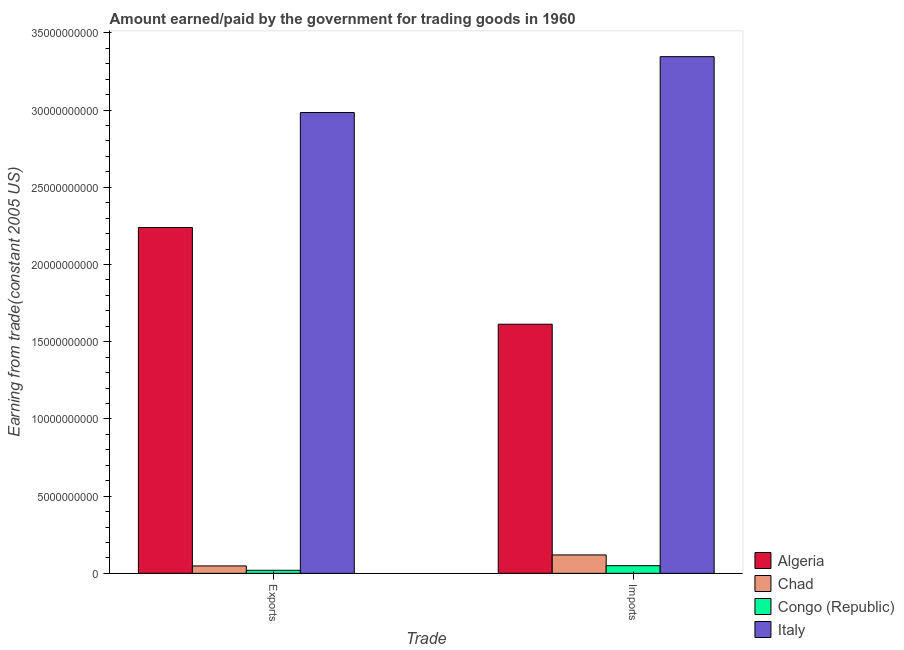How many different coloured bars are there?
Ensure brevity in your answer.  4. How many groups of bars are there?
Make the answer very short. 2. How many bars are there on the 1st tick from the right?
Make the answer very short. 4. What is the label of the 1st group of bars from the left?
Make the answer very short. Exports. What is the amount earned from exports in Chad?
Your answer should be compact. 4.79e+08. Across all countries, what is the maximum amount paid for imports?
Give a very brief answer. 3.35e+1. Across all countries, what is the minimum amount paid for imports?
Your response must be concise. 4.95e+08. In which country was the amount earned from exports minimum?
Keep it short and to the point. Congo (Republic). What is the total amount earned from exports in the graph?
Ensure brevity in your answer.  5.29e+1. What is the difference between the amount earned from exports in Algeria and that in Chad?
Keep it short and to the point. 2.19e+1. What is the difference between the amount paid for imports in Algeria and the amount earned from exports in Congo (Republic)?
Your answer should be compact. 1.59e+1. What is the average amount paid for imports per country?
Provide a short and direct response. 1.28e+1. What is the difference between the amount paid for imports and amount earned from exports in Italy?
Your answer should be compact. 3.62e+09. In how many countries, is the amount earned from exports greater than 19000000000 US$?
Your response must be concise. 2. What is the ratio of the amount earned from exports in Congo (Republic) to that in Algeria?
Make the answer very short. 0.01. What does the 2nd bar from the left in Imports represents?
Offer a very short reply. Chad. What does the 4th bar from the right in Exports represents?
Your answer should be very brief. Algeria. How many bars are there?
Your answer should be very brief. 8. How many countries are there in the graph?
Your response must be concise. 4. Does the graph contain grids?
Ensure brevity in your answer.  No. Where does the legend appear in the graph?
Provide a short and direct response. Bottom right. How many legend labels are there?
Offer a terse response. 4. What is the title of the graph?
Offer a very short reply. Amount earned/paid by the government for trading goods in 1960. Does "Uzbekistan" appear as one of the legend labels in the graph?
Make the answer very short. No. What is the label or title of the X-axis?
Give a very brief answer. Trade. What is the label or title of the Y-axis?
Make the answer very short. Earning from trade(constant 2005 US). What is the Earning from trade(constant 2005 US) in Algeria in Exports?
Keep it short and to the point. 2.24e+1. What is the Earning from trade(constant 2005 US) of Chad in Exports?
Make the answer very short. 4.79e+08. What is the Earning from trade(constant 2005 US) in Congo (Republic) in Exports?
Keep it short and to the point. 1.98e+08. What is the Earning from trade(constant 2005 US) in Italy in Exports?
Keep it short and to the point. 2.98e+1. What is the Earning from trade(constant 2005 US) in Algeria in Imports?
Your answer should be very brief. 1.61e+1. What is the Earning from trade(constant 2005 US) of Chad in Imports?
Ensure brevity in your answer.  1.19e+09. What is the Earning from trade(constant 2005 US) of Congo (Republic) in Imports?
Your answer should be very brief. 4.95e+08. What is the Earning from trade(constant 2005 US) of Italy in Imports?
Keep it short and to the point. 3.35e+1. Across all Trade, what is the maximum Earning from trade(constant 2005 US) in Algeria?
Offer a very short reply. 2.24e+1. Across all Trade, what is the maximum Earning from trade(constant 2005 US) of Chad?
Your response must be concise. 1.19e+09. Across all Trade, what is the maximum Earning from trade(constant 2005 US) of Congo (Republic)?
Offer a very short reply. 4.95e+08. Across all Trade, what is the maximum Earning from trade(constant 2005 US) in Italy?
Give a very brief answer. 3.35e+1. Across all Trade, what is the minimum Earning from trade(constant 2005 US) of Algeria?
Your answer should be compact. 1.61e+1. Across all Trade, what is the minimum Earning from trade(constant 2005 US) of Chad?
Make the answer very short. 4.79e+08. Across all Trade, what is the minimum Earning from trade(constant 2005 US) in Congo (Republic)?
Keep it short and to the point. 1.98e+08. Across all Trade, what is the minimum Earning from trade(constant 2005 US) of Italy?
Offer a very short reply. 2.98e+1. What is the total Earning from trade(constant 2005 US) of Algeria in the graph?
Provide a short and direct response. 3.85e+1. What is the total Earning from trade(constant 2005 US) of Chad in the graph?
Provide a short and direct response. 1.67e+09. What is the total Earning from trade(constant 2005 US) in Congo (Republic) in the graph?
Your answer should be compact. 6.93e+08. What is the total Earning from trade(constant 2005 US) in Italy in the graph?
Provide a short and direct response. 6.33e+1. What is the difference between the Earning from trade(constant 2005 US) of Algeria in Exports and that in Imports?
Provide a short and direct response. 6.26e+09. What is the difference between the Earning from trade(constant 2005 US) in Chad in Exports and that in Imports?
Your answer should be very brief. -7.13e+08. What is the difference between the Earning from trade(constant 2005 US) in Congo (Republic) in Exports and that in Imports?
Provide a short and direct response. -2.96e+08. What is the difference between the Earning from trade(constant 2005 US) of Italy in Exports and that in Imports?
Offer a terse response. -3.62e+09. What is the difference between the Earning from trade(constant 2005 US) of Algeria in Exports and the Earning from trade(constant 2005 US) of Chad in Imports?
Provide a short and direct response. 2.12e+1. What is the difference between the Earning from trade(constant 2005 US) in Algeria in Exports and the Earning from trade(constant 2005 US) in Congo (Republic) in Imports?
Provide a succinct answer. 2.19e+1. What is the difference between the Earning from trade(constant 2005 US) of Algeria in Exports and the Earning from trade(constant 2005 US) of Italy in Imports?
Keep it short and to the point. -1.11e+1. What is the difference between the Earning from trade(constant 2005 US) in Chad in Exports and the Earning from trade(constant 2005 US) in Congo (Republic) in Imports?
Provide a succinct answer. -1.58e+07. What is the difference between the Earning from trade(constant 2005 US) in Chad in Exports and the Earning from trade(constant 2005 US) in Italy in Imports?
Make the answer very short. -3.30e+1. What is the difference between the Earning from trade(constant 2005 US) in Congo (Republic) in Exports and the Earning from trade(constant 2005 US) in Italy in Imports?
Ensure brevity in your answer.  -3.33e+1. What is the average Earning from trade(constant 2005 US) in Algeria per Trade?
Provide a short and direct response. 1.93e+1. What is the average Earning from trade(constant 2005 US) in Chad per Trade?
Offer a terse response. 8.35e+08. What is the average Earning from trade(constant 2005 US) of Congo (Republic) per Trade?
Keep it short and to the point. 3.46e+08. What is the average Earning from trade(constant 2005 US) of Italy per Trade?
Provide a short and direct response. 3.16e+1. What is the difference between the Earning from trade(constant 2005 US) of Algeria and Earning from trade(constant 2005 US) of Chad in Exports?
Keep it short and to the point. 2.19e+1. What is the difference between the Earning from trade(constant 2005 US) of Algeria and Earning from trade(constant 2005 US) of Congo (Republic) in Exports?
Offer a terse response. 2.22e+1. What is the difference between the Earning from trade(constant 2005 US) of Algeria and Earning from trade(constant 2005 US) of Italy in Exports?
Give a very brief answer. -7.45e+09. What is the difference between the Earning from trade(constant 2005 US) of Chad and Earning from trade(constant 2005 US) of Congo (Republic) in Exports?
Provide a short and direct response. 2.81e+08. What is the difference between the Earning from trade(constant 2005 US) of Chad and Earning from trade(constant 2005 US) of Italy in Exports?
Your answer should be compact. -2.94e+1. What is the difference between the Earning from trade(constant 2005 US) in Congo (Republic) and Earning from trade(constant 2005 US) in Italy in Exports?
Your response must be concise. -2.96e+1. What is the difference between the Earning from trade(constant 2005 US) of Algeria and Earning from trade(constant 2005 US) of Chad in Imports?
Provide a short and direct response. 1.49e+1. What is the difference between the Earning from trade(constant 2005 US) of Algeria and Earning from trade(constant 2005 US) of Congo (Republic) in Imports?
Give a very brief answer. 1.56e+1. What is the difference between the Earning from trade(constant 2005 US) of Algeria and Earning from trade(constant 2005 US) of Italy in Imports?
Your answer should be compact. -1.73e+1. What is the difference between the Earning from trade(constant 2005 US) in Chad and Earning from trade(constant 2005 US) in Congo (Republic) in Imports?
Provide a succinct answer. 6.97e+08. What is the difference between the Earning from trade(constant 2005 US) in Chad and Earning from trade(constant 2005 US) in Italy in Imports?
Keep it short and to the point. -3.23e+1. What is the difference between the Earning from trade(constant 2005 US) in Congo (Republic) and Earning from trade(constant 2005 US) in Italy in Imports?
Keep it short and to the point. -3.30e+1. What is the ratio of the Earning from trade(constant 2005 US) in Algeria in Exports to that in Imports?
Your answer should be compact. 1.39. What is the ratio of the Earning from trade(constant 2005 US) of Chad in Exports to that in Imports?
Offer a very short reply. 0.4. What is the ratio of the Earning from trade(constant 2005 US) of Congo (Republic) in Exports to that in Imports?
Ensure brevity in your answer.  0.4. What is the ratio of the Earning from trade(constant 2005 US) of Italy in Exports to that in Imports?
Provide a succinct answer. 0.89. What is the difference between the highest and the second highest Earning from trade(constant 2005 US) in Algeria?
Your answer should be compact. 6.26e+09. What is the difference between the highest and the second highest Earning from trade(constant 2005 US) in Chad?
Offer a terse response. 7.13e+08. What is the difference between the highest and the second highest Earning from trade(constant 2005 US) of Congo (Republic)?
Ensure brevity in your answer.  2.96e+08. What is the difference between the highest and the second highest Earning from trade(constant 2005 US) in Italy?
Give a very brief answer. 3.62e+09. What is the difference between the highest and the lowest Earning from trade(constant 2005 US) of Algeria?
Offer a very short reply. 6.26e+09. What is the difference between the highest and the lowest Earning from trade(constant 2005 US) of Chad?
Your answer should be compact. 7.13e+08. What is the difference between the highest and the lowest Earning from trade(constant 2005 US) of Congo (Republic)?
Your answer should be compact. 2.96e+08. What is the difference between the highest and the lowest Earning from trade(constant 2005 US) in Italy?
Offer a terse response. 3.62e+09. 